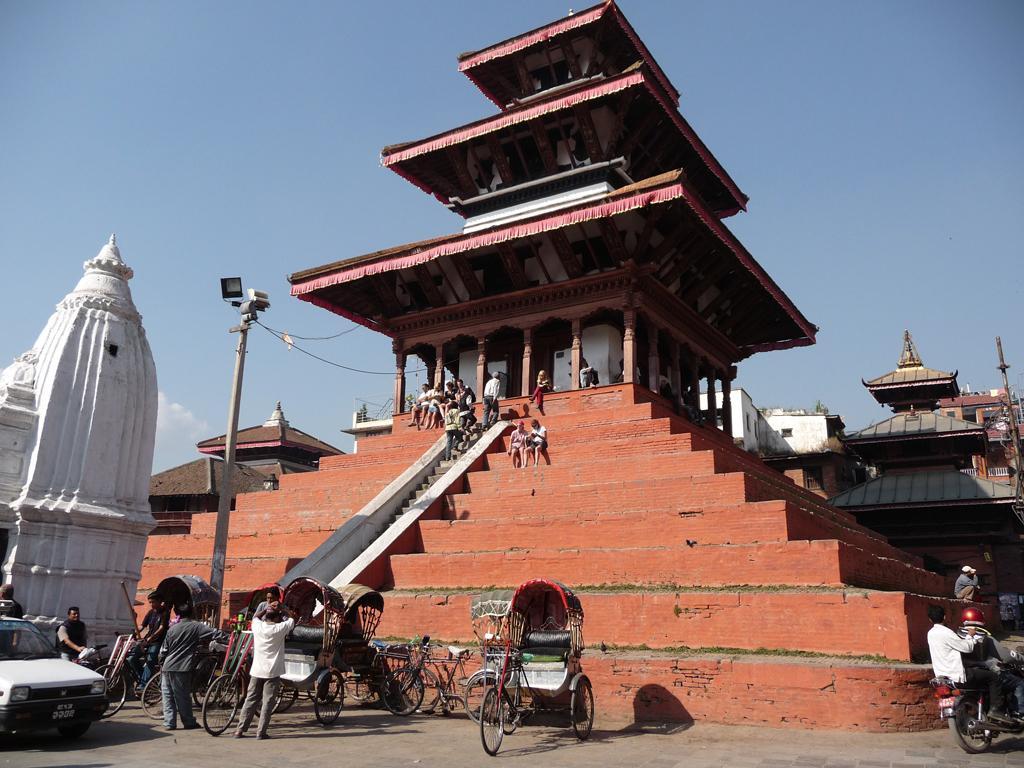How would you summarize this image in a sentence or two? In this image we can see a building with pillars and some people sitting on the stairs. We can also see some people walking upstairs. On the bottom of the image we can see some rickshaws, a car and a motor vehicle on the road. We can also see some people standing. On the left side we can see a temple and a pole with lights and wires. On the right side we can see some buildings and and the sky which looks cloudy. 